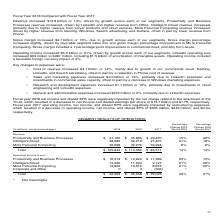According to Microsoft Corporation's financial document, Why did corporate and other operating loss decrease in 2018? Based on the financial document, the answer is due to a reduction in restructuring expenses, driven by employee severance expenses primarily related to our sales and marketing restructuring plan in fiscal year 2017.. Also, Why did revenue increase on Office 365 Commercial in 2019 from 2018? Based on the financial document, the answer is due to growth in seats and higher average revenue per user. Also, Why did server products revenue increase 6%? Based on the financial document, the answer is due to continued demand for premium versions and hybrid solutions, GitHub, and demand ahead of end-of-support for SQL Server 2008 and Windows Server 2008.. Also, can you calculate: What was the intelligent cloud as a percentage of total revenue in 2019? Based on the calculation: 38,985/125,843, the result is 30.98 (percentage). This is based on the information: "Total $ 125,843 $ 110,360 $ 96,571 14% 14% Intelligent Cloud 38,985 32,219 27,407 21% 18%..." The key data points involved are: 125,843, 38,985. Also, How many revenue categories are there? Counting the relevant items in the document: Productivity and Business Processes, Intelligent Cloud, More Personal Computing, I find 3 instances. The key data points involved are: Intelligent Cloud, More Personal Computing, Productivity and Business Processes. Also, can you calculate: What is the average operating income from 2017 to 2019? To answer this question, I need to perform calculations using the financial data. The calculation is: (42,959+35,058+29,025)/3, which equals 35680.67 (in millions). This is based on the information: "Total $ 42,959 $ 35,058 $ 29,025 23% 21% Total $ 42,959 $ 35,058 $ 29,025 23% 21% Total $ 42,959 $ 35,058 $ 29,025 23% 21%..." The key data points involved are: 29,025, 35,058, 42,959. 